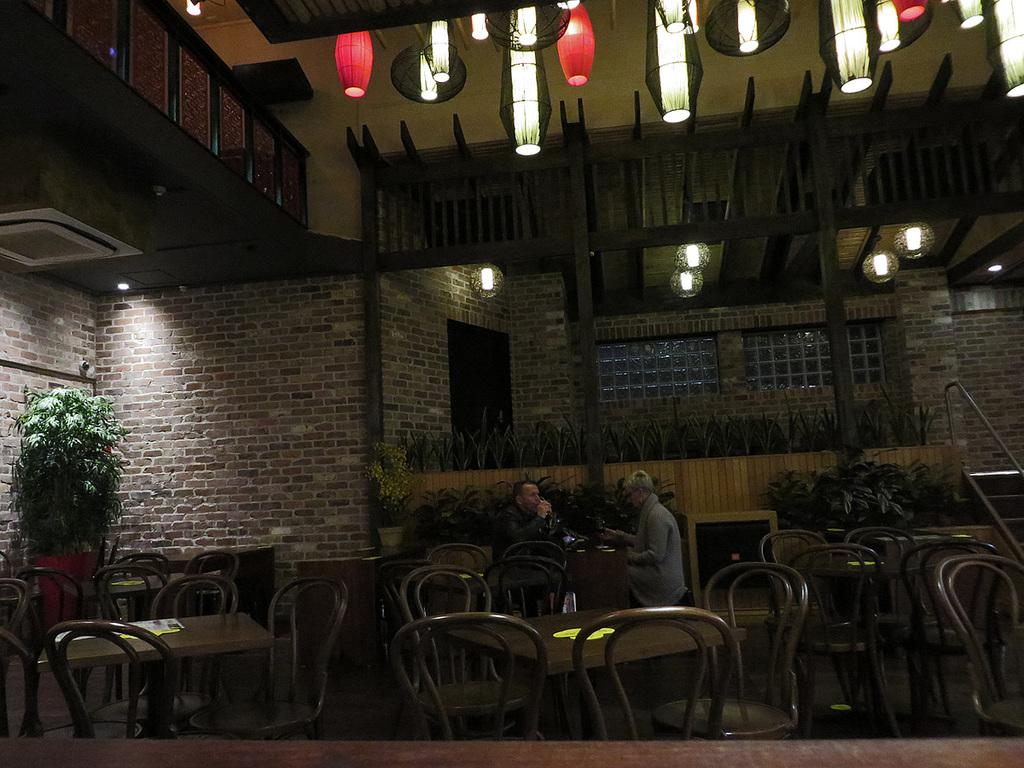What is the main object in the image? There is a table in the image. What are the two persons doing while sitting on chairs? The two persons are sitting on chairs in the image. Where is the flower pot located in the image? The flower pot is at the back side of the image. What type of cake is being served on the table in the image? There is no cake present in the image; it only shows a table, two persons sitting on chairs, and a flower pot at the back side. 